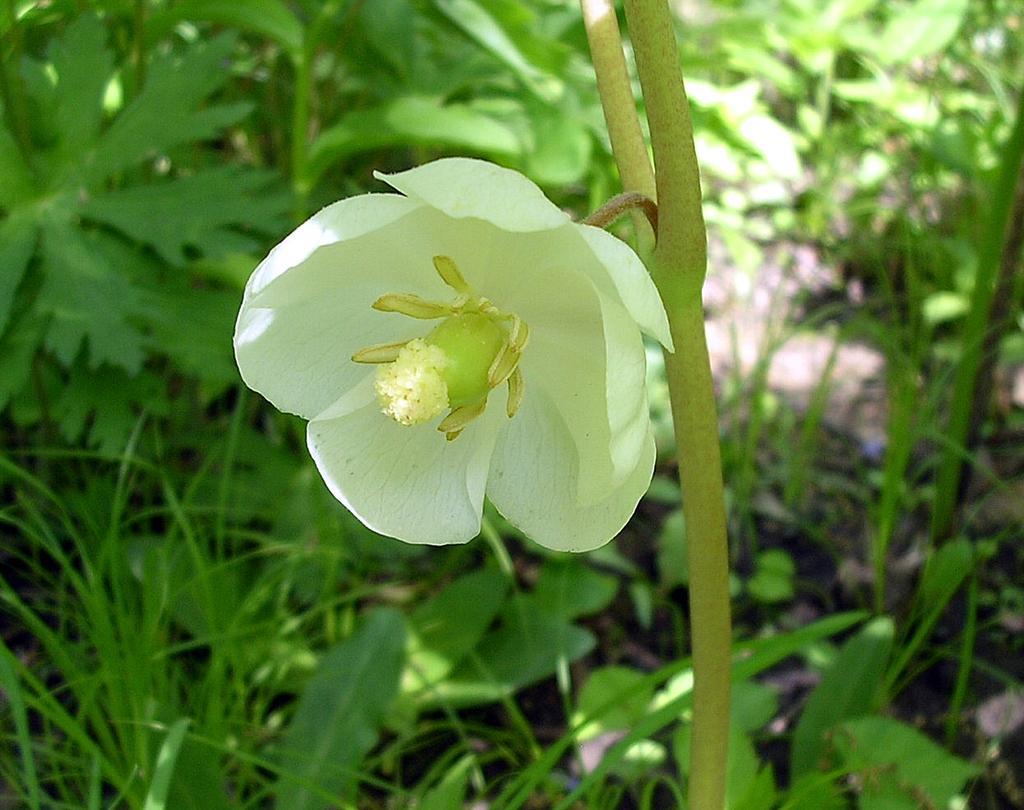How would you summarize this image in a sentence or two? In this image there is a white color flower to the plant. At the bottom there is grass. In the background there are plants with green leaves. 